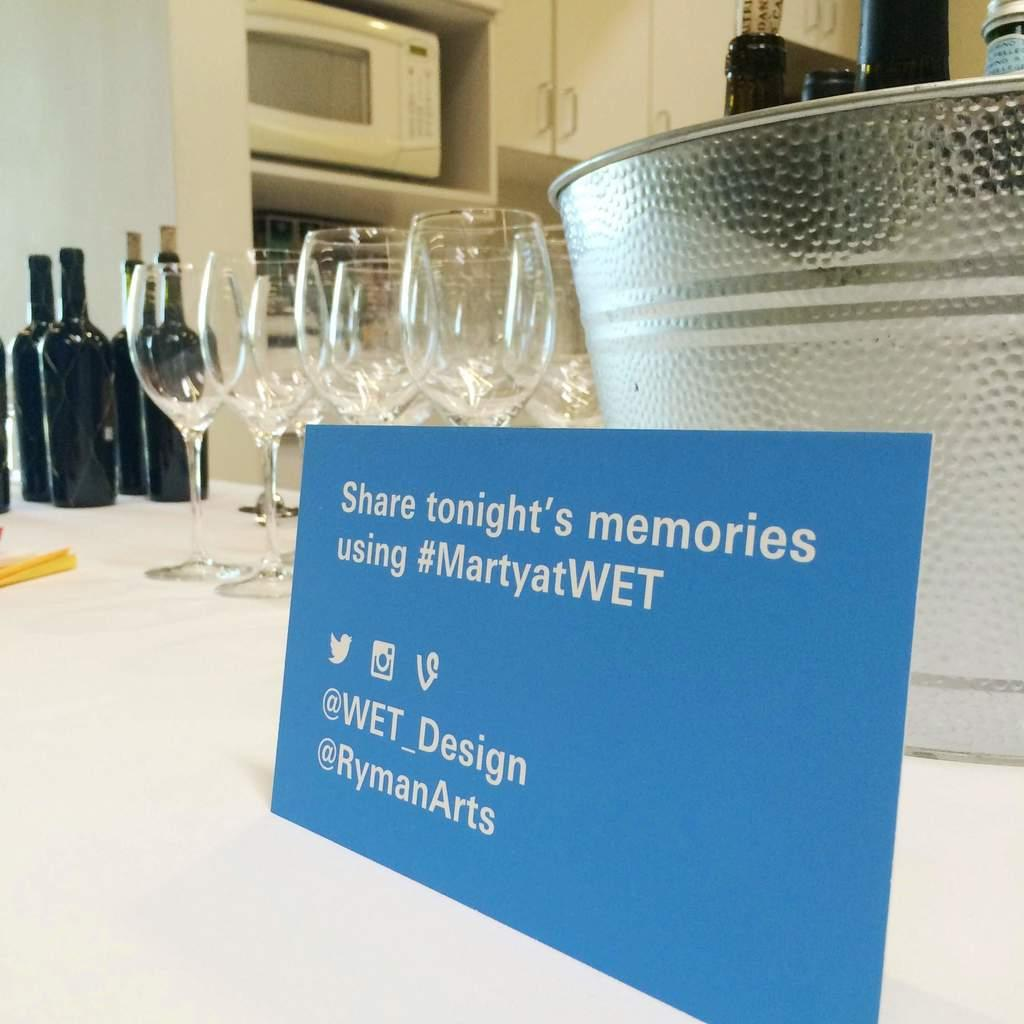<image>
Create a compact narrative representing the image presented. A table has wine glasses and wine bottles with a sign that says Share tonight's memories using #MartyatWET. 